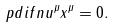<formula> <loc_0><loc_0><loc_500><loc_500>\ p d i f { n u ^ { \mu } } { x ^ { \mu } } = 0 .</formula> 